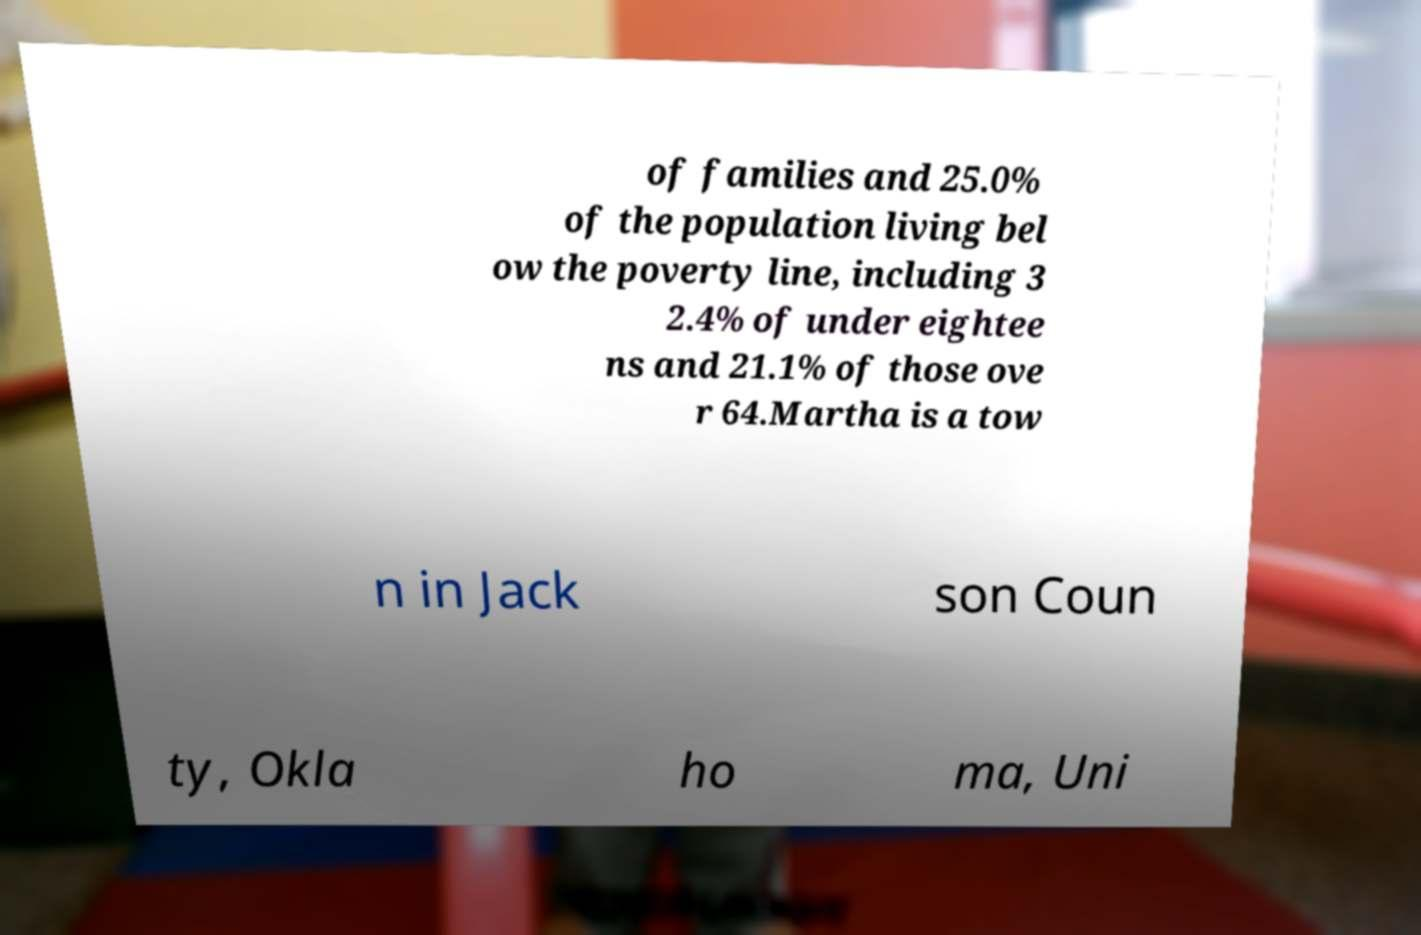For documentation purposes, I need the text within this image transcribed. Could you provide that? of families and 25.0% of the population living bel ow the poverty line, including 3 2.4% of under eightee ns and 21.1% of those ove r 64.Martha is a tow n in Jack son Coun ty, Okla ho ma, Uni 